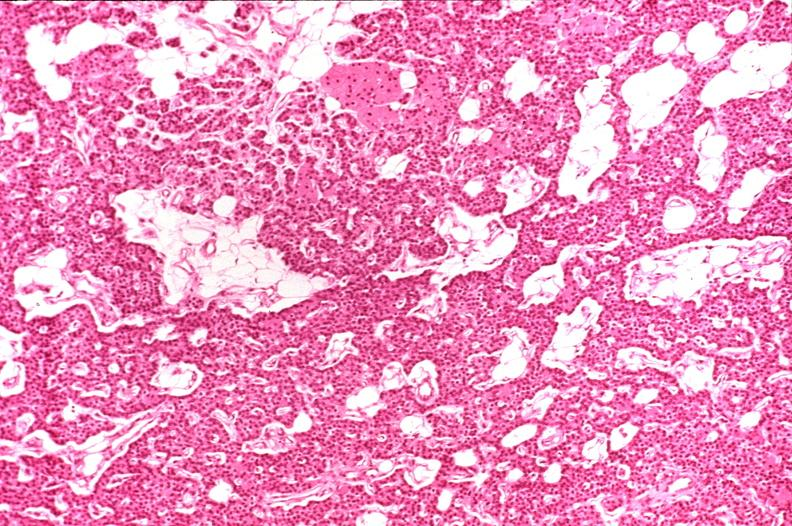what does this image show?
Answer the question using a single word or phrase. Parathyroid 